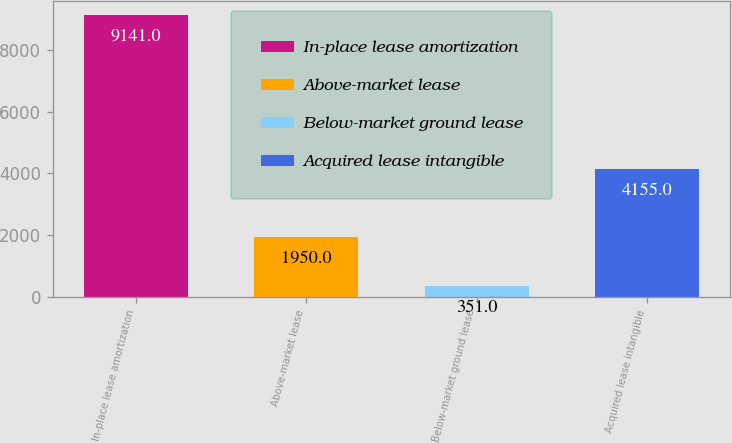Convert chart to OTSL. <chart><loc_0><loc_0><loc_500><loc_500><bar_chart><fcel>In-place lease amortization<fcel>Above-market lease<fcel>Below-market ground lease<fcel>Acquired lease intangible<nl><fcel>9141<fcel>1950<fcel>351<fcel>4155<nl></chart> 